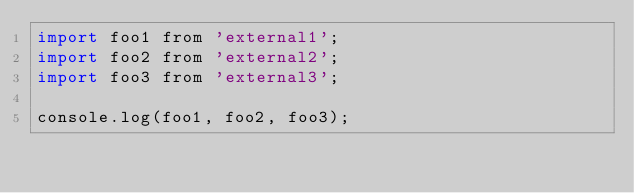Convert code to text. <code><loc_0><loc_0><loc_500><loc_500><_JavaScript_>import foo1 from 'external1';
import foo2 from 'external2';
import foo3 from 'external3';

console.log(foo1, foo2, foo3);
</code> 